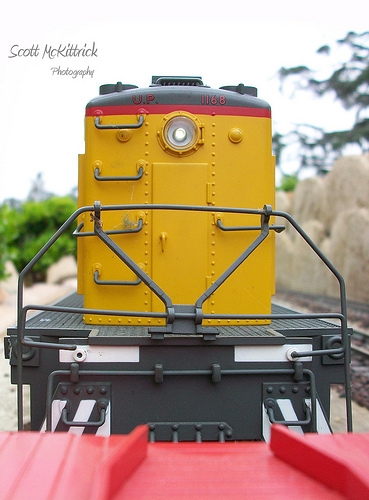<image>
Is there a sky behind the tree? Yes. From this viewpoint, the sky is positioned behind the tree, with the tree partially or fully occluding the sky. 